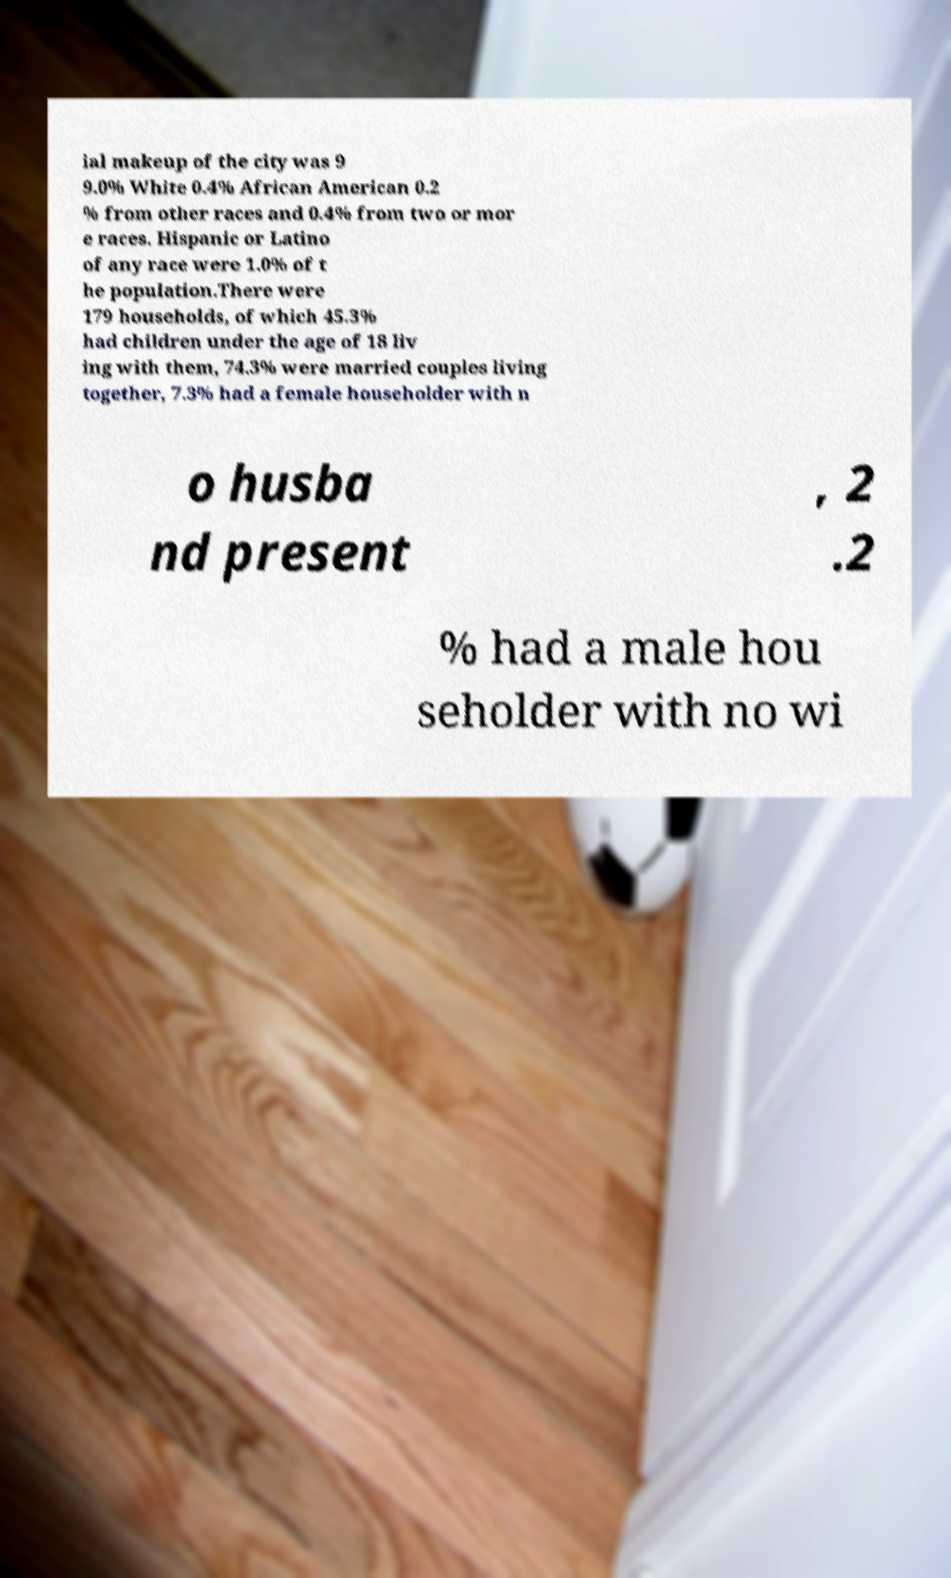What messages or text are displayed in this image? I need them in a readable, typed format. ial makeup of the city was 9 9.0% White 0.4% African American 0.2 % from other races and 0.4% from two or mor e races. Hispanic or Latino of any race were 1.0% of t he population.There were 179 households, of which 45.3% had children under the age of 18 liv ing with them, 74.3% were married couples living together, 7.3% had a female householder with n o husba nd present , 2 .2 % had a male hou seholder with no wi 